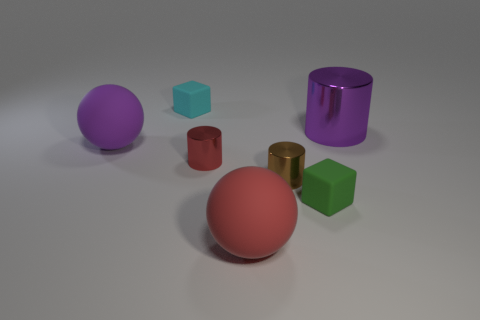Does the brown cylinder have the same size as the block on the right side of the big red rubber ball?
Offer a very short reply. Yes. What number of things are tiny metal things or red metallic cylinders?
Offer a very short reply. 2. Is there a green cube that has the same material as the tiny green thing?
Make the answer very short. No. The object that is the same color as the big cylinder is what size?
Keep it short and to the point. Large. What is the color of the small object that is behind the big matte thing behind the green matte cube?
Offer a very short reply. Cyan. Do the cyan rubber object and the brown metallic cylinder have the same size?
Your response must be concise. Yes. What number of blocks are either purple rubber things or tiny brown metal things?
Keep it short and to the point. 0. What number of large purple rubber objects are on the right side of the matte block in front of the tiny brown metallic object?
Give a very brief answer. 0. Is the small brown thing the same shape as the red matte object?
Your answer should be compact. No. There is a green rubber object that is the same shape as the cyan object; what size is it?
Offer a very short reply. Small. 